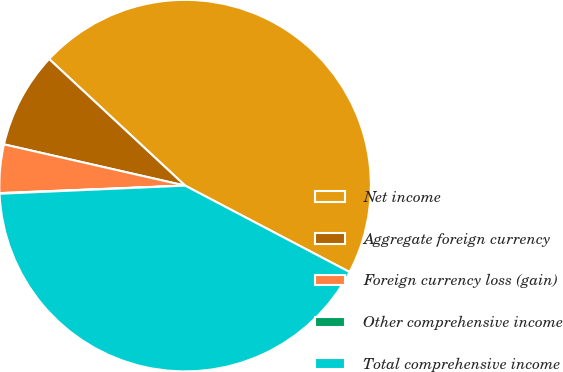Convert chart. <chart><loc_0><loc_0><loc_500><loc_500><pie_chart><fcel>Net income<fcel>Aggregate foreign currency<fcel>Foreign currency loss (gain)<fcel>Other comprehensive income<fcel>Total comprehensive income<nl><fcel>45.77%<fcel>8.37%<fcel>4.21%<fcel>0.05%<fcel>41.61%<nl></chart> 